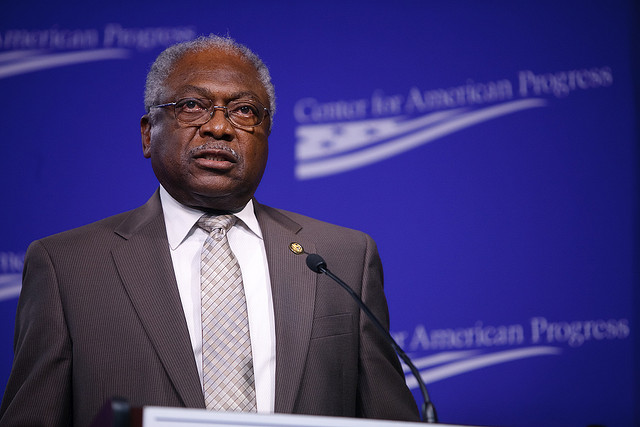Read all the text in this image. American for Progress Progress American 